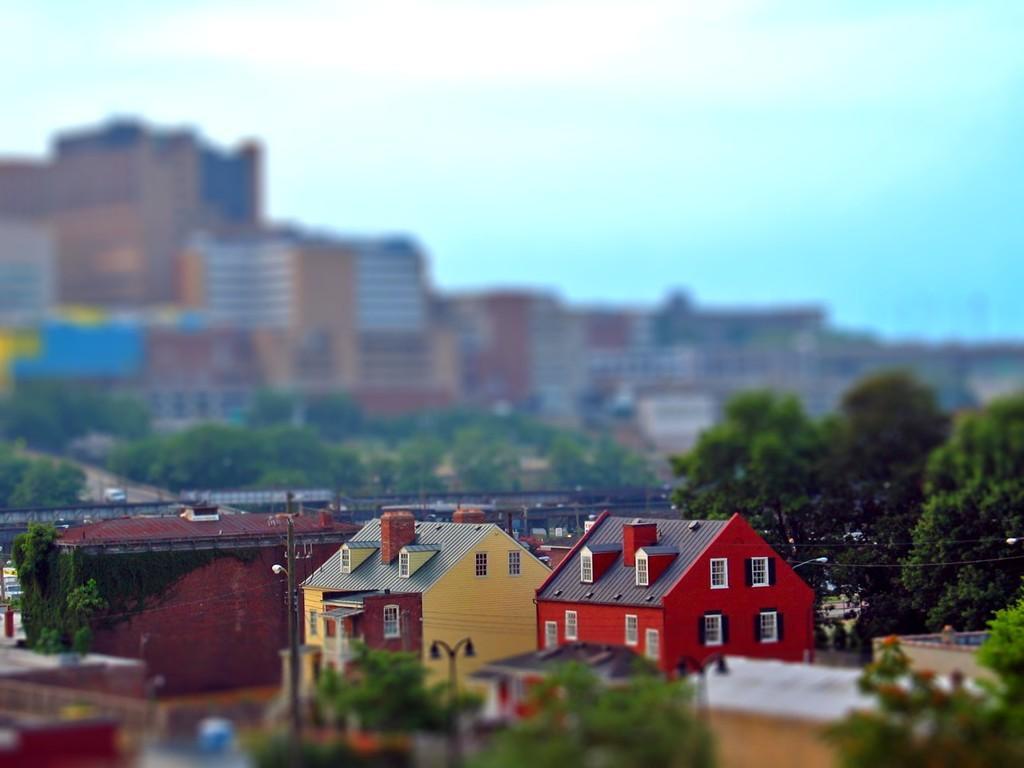Please provide a concise description of this image. In this image there are houses, trees, buildings and the sky, in the background it is blurred. 